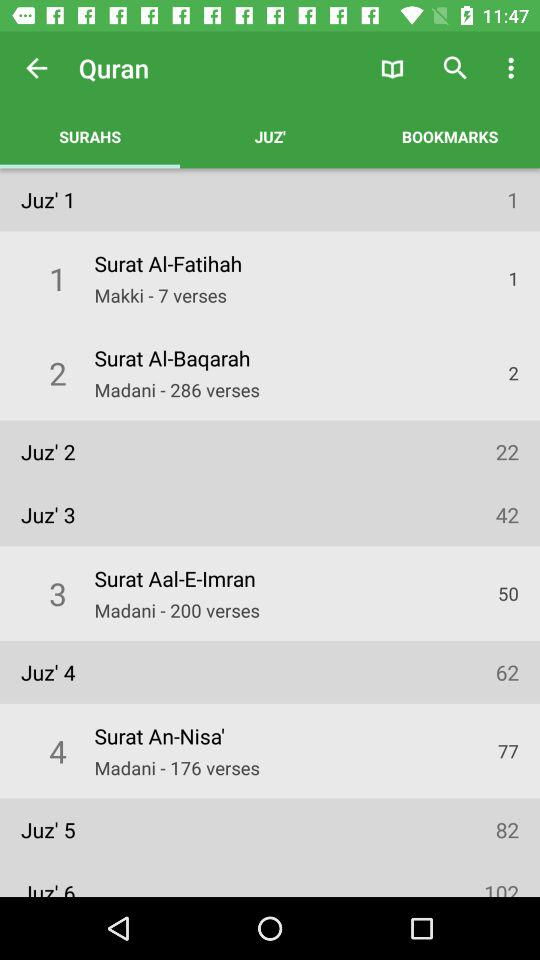How many verses are in Surat Al-Baqarah?
Answer the question using a single word or phrase. 286 